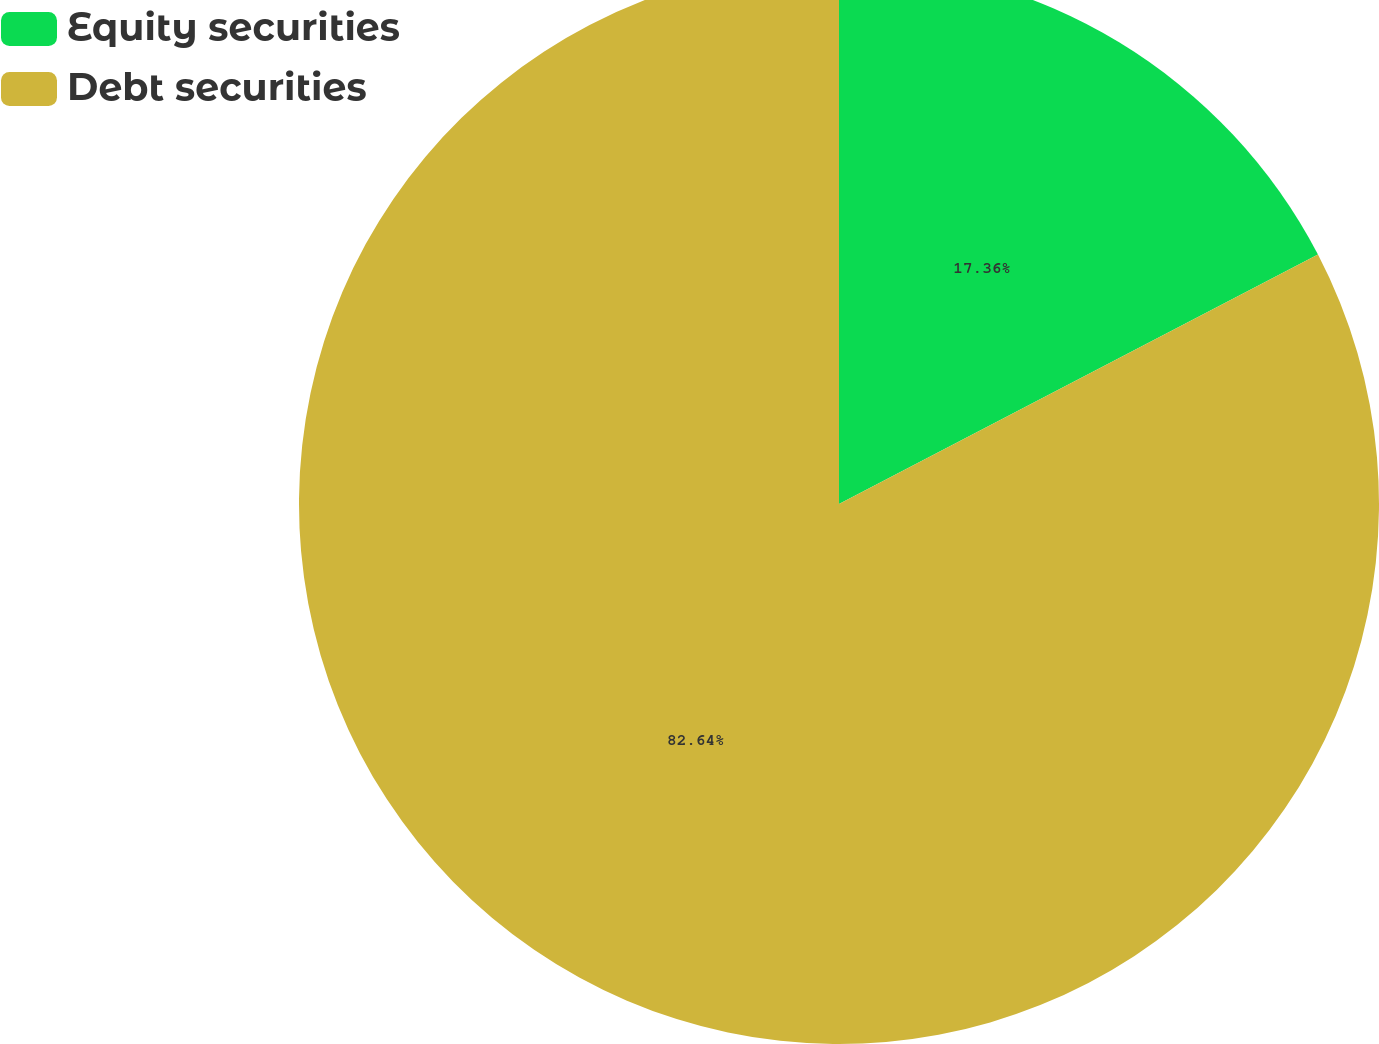<chart> <loc_0><loc_0><loc_500><loc_500><pie_chart><fcel>Equity securities<fcel>Debt securities<nl><fcel>17.36%<fcel>82.64%<nl></chart> 